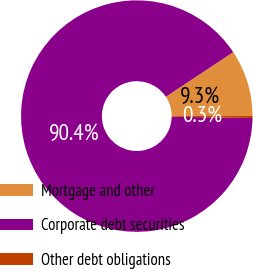<chart> <loc_0><loc_0><loc_500><loc_500><pie_chart><fcel>Mortgage and other<fcel>Corporate debt securities<fcel>Other debt obligations<nl><fcel>9.3%<fcel>90.41%<fcel>0.29%<nl></chart> 